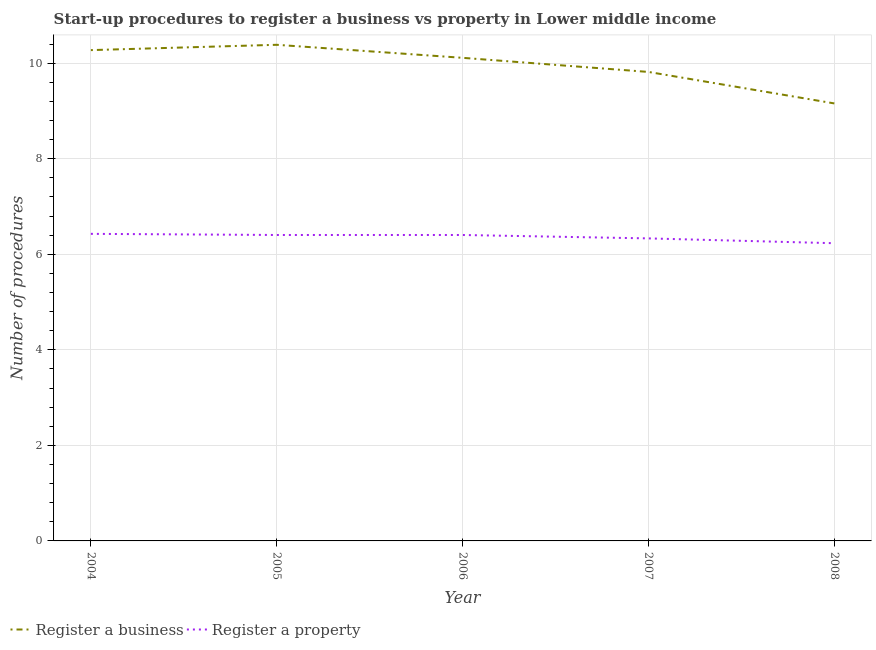How many different coloured lines are there?
Provide a succinct answer. 2. Is the number of lines equal to the number of legend labels?
Your answer should be compact. Yes. What is the number of procedures to register a business in 2006?
Provide a short and direct response. 10.11. Across all years, what is the maximum number of procedures to register a property?
Offer a very short reply. 6.43. Across all years, what is the minimum number of procedures to register a property?
Your response must be concise. 6.23. In which year was the number of procedures to register a business maximum?
Your answer should be compact. 2005. What is the total number of procedures to register a property in the graph?
Offer a very short reply. 31.8. What is the difference between the number of procedures to register a business in 2005 and that in 2007?
Your answer should be compact. 0.57. What is the difference between the number of procedures to register a business in 2005 and the number of procedures to register a property in 2006?
Keep it short and to the point. 3.98. What is the average number of procedures to register a property per year?
Make the answer very short. 6.36. In the year 2008, what is the difference between the number of procedures to register a business and number of procedures to register a property?
Ensure brevity in your answer.  2.93. What is the ratio of the number of procedures to register a business in 2004 to that in 2006?
Your answer should be very brief. 1.02. What is the difference between the highest and the second highest number of procedures to register a business?
Provide a short and direct response. 0.11. What is the difference between the highest and the lowest number of procedures to register a property?
Make the answer very short. 0.2. Is the sum of the number of procedures to register a property in 2005 and 2008 greater than the maximum number of procedures to register a business across all years?
Your response must be concise. Yes. How many years are there in the graph?
Keep it short and to the point. 5. Are the values on the major ticks of Y-axis written in scientific E-notation?
Ensure brevity in your answer.  No. Where does the legend appear in the graph?
Your response must be concise. Bottom left. How are the legend labels stacked?
Your answer should be compact. Horizontal. What is the title of the graph?
Ensure brevity in your answer.  Start-up procedures to register a business vs property in Lower middle income. Does "Excluding technical cooperation" appear as one of the legend labels in the graph?
Give a very brief answer. No. What is the label or title of the Y-axis?
Ensure brevity in your answer.  Number of procedures. What is the Number of procedures in Register a business in 2004?
Provide a short and direct response. 10.28. What is the Number of procedures in Register a property in 2004?
Offer a very short reply. 6.43. What is the Number of procedures in Register a business in 2005?
Keep it short and to the point. 10.39. What is the Number of procedures of Register a property in 2005?
Your answer should be very brief. 6.4. What is the Number of procedures of Register a business in 2006?
Provide a short and direct response. 10.11. What is the Number of procedures in Register a property in 2006?
Make the answer very short. 6.4. What is the Number of procedures of Register a business in 2007?
Keep it short and to the point. 9.82. What is the Number of procedures of Register a property in 2007?
Your answer should be compact. 6.33. What is the Number of procedures in Register a business in 2008?
Your answer should be very brief. 9.16. What is the Number of procedures in Register a property in 2008?
Your answer should be compact. 6.23. Across all years, what is the maximum Number of procedures of Register a business?
Offer a very short reply. 10.39. Across all years, what is the maximum Number of procedures in Register a property?
Your answer should be compact. 6.43. Across all years, what is the minimum Number of procedures in Register a business?
Provide a short and direct response. 9.16. Across all years, what is the minimum Number of procedures in Register a property?
Give a very brief answer. 6.23. What is the total Number of procedures of Register a business in the graph?
Provide a short and direct response. 49.75. What is the total Number of procedures of Register a property in the graph?
Offer a very short reply. 31.8. What is the difference between the Number of procedures in Register a business in 2004 and that in 2005?
Offer a very short reply. -0.11. What is the difference between the Number of procedures of Register a property in 2004 and that in 2005?
Your answer should be compact. 0.02. What is the difference between the Number of procedures of Register a business in 2004 and that in 2006?
Your response must be concise. 0.16. What is the difference between the Number of procedures in Register a property in 2004 and that in 2006?
Your answer should be very brief. 0.02. What is the difference between the Number of procedures of Register a business in 2004 and that in 2007?
Give a very brief answer. 0.46. What is the difference between the Number of procedures of Register a property in 2004 and that in 2007?
Keep it short and to the point. 0.1. What is the difference between the Number of procedures of Register a business in 2004 and that in 2008?
Ensure brevity in your answer.  1.12. What is the difference between the Number of procedures of Register a property in 2004 and that in 2008?
Provide a succinct answer. 0.2. What is the difference between the Number of procedures in Register a business in 2005 and that in 2006?
Ensure brevity in your answer.  0.27. What is the difference between the Number of procedures of Register a property in 2005 and that in 2006?
Your response must be concise. 0. What is the difference between the Number of procedures in Register a business in 2005 and that in 2007?
Offer a very short reply. 0.57. What is the difference between the Number of procedures in Register a property in 2005 and that in 2007?
Your answer should be compact. 0.07. What is the difference between the Number of procedures of Register a business in 2005 and that in 2008?
Give a very brief answer. 1.23. What is the difference between the Number of procedures in Register a property in 2005 and that in 2008?
Provide a short and direct response. 0.17. What is the difference between the Number of procedures in Register a business in 2006 and that in 2007?
Provide a short and direct response. 0.3. What is the difference between the Number of procedures of Register a property in 2006 and that in 2007?
Your response must be concise. 0.07. What is the difference between the Number of procedures of Register a business in 2006 and that in 2008?
Keep it short and to the point. 0.95. What is the difference between the Number of procedures of Register a property in 2006 and that in 2008?
Your response must be concise. 0.17. What is the difference between the Number of procedures of Register a business in 2007 and that in 2008?
Give a very brief answer. 0.66. What is the difference between the Number of procedures in Register a property in 2007 and that in 2008?
Your answer should be compact. 0.1. What is the difference between the Number of procedures in Register a business in 2004 and the Number of procedures in Register a property in 2005?
Provide a succinct answer. 3.87. What is the difference between the Number of procedures in Register a business in 2004 and the Number of procedures in Register a property in 2006?
Your answer should be very brief. 3.87. What is the difference between the Number of procedures in Register a business in 2004 and the Number of procedures in Register a property in 2007?
Offer a terse response. 3.94. What is the difference between the Number of procedures of Register a business in 2004 and the Number of procedures of Register a property in 2008?
Make the answer very short. 4.04. What is the difference between the Number of procedures in Register a business in 2005 and the Number of procedures in Register a property in 2006?
Give a very brief answer. 3.98. What is the difference between the Number of procedures of Register a business in 2005 and the Number of procedures of Register a property in 2007?
Provide a short and direct response. 4.05. What is the difference between the Number of procedures in Register a business in 2005 and the Number of procedures in Register a property in 2008?
Your answer should be very brief. 4.15. What is the difference between the Number of procedures of Register a business in 2006 and the Number of procedures of Register a property in 2007?
Ensure brevity in your answer.  3.78. What is the difference between the Number of procedures in Register a business in 2006 and the Number of procedures in Register a property in 2008?
Your response must be concise. 3.88. What is the difference between the Number of procedures in Register a business in 2007 and the Number of procedures in Register a property in 2008?
Your answer should be compact. 3.59. What is the average Number of procedures of Register a business per year?
Keep it short and to the point. 9.95. What is the average Number of procedures of Register a property per year?
Provide a short and direct response. 6.36. In the year 2004, what is the difference between the Number of procedures of Register a business and Number of procedures of Register a property?
Ensure brevity in your answer.  3.85. In the year 2005, what is the difference between the Number of procedures of Register a business and Number of procedures of Register a property?
Your response must be concise. 3.98. In the year 2006, what is the difference between the Number of procedures in Register a business and Number of procedures in Register a property?
Give a very brief answer. 3.71. In the year 2007, what is the difference between the Number of procedures of Register a business and Number of procedures of Register a property?
Make the answer very short. 3.48. In the year 2008, what is the difference between the Number of procedures of Register a business and Number of procedures of Register a property?
Offer a very short reply. 2.93. What is the ratio of the Number of procedures in Register a business in 2004 to that in 2005?
Ensure brevity in your answer.  0.99. What is the ratio of the Number of procedures of Register a business in 2004 to that in 2006?
Your response must be concise. 1.02. What is the ratio of the Number of procedures in Register a property in 2004 to that in 2006?
Offer a terse response. 1. What is the ratio of the Number of procedures of Register a business in 2004 to that in 2007?
Give a very brief answer. 1.05. What is the ratio of the Number of procedures in Register a property in 2004 to that in 2007?
Keep it short and to the point. 1.01. What is the ratio of the Number of procedures in Register a business in 2004 to that in 2008?
Offer a terse response. 1.12. What is the ratio of the Number of procedures of Register a property in 2004 to that in 2008?
Provide a short and direct response. 1.03. What is the ratio of the Number of procedures of Register a business in 2005 to that in 2007?
Your answer should be very brief. 1.06. What is the ratio of the Number of procedures of Register a property in 2005 to that in 2007?
Keep it short and to the point. 1.01. What is the ratio of the Number of procedures in Register a business in 2005 to that in 2008?
Offer a very short reply. 1.13. What is the ratio of the Number of procedures of Register a property in 2005 to that in 2008?
Offer a very short reply. 1.03. What is the ratio of the Number of procedures in Register a business in 2006 to that in 2007?
Ensure brevity in your answer.  1.03. What is the ratio of the Number of procedures in Register a property in 2006 to that in 2007?
Ensure brevity in your answer.  1.01. What is the ratio of the Number of procedures in Register a business in 2006 to that in 2008?
Provide a short and direct response. 1.1. What is the ratio of the Number of procedures in Register a property in 2006 to that in 2008?
Your answer should be compact. 1.03. What is the ratio of the Number of procedures of Register a business in 2007 to that in 2008?
Make the answer very short. 1.07. What is the ratio of the Number of procedures in Register a property in 2007 to that in 2008?
Offer a terse response. 1.02. What is the difference between the highest and the second highest Number of procedures in Register a business?
Provide a succinct answer. 0.11. What is the difference between the highest and the second highest Number of procedures of Register a property?
Ensure brevity in your answer.  0.02. What is the difference between the highest and the lowest Number of procedures in Register a business?
Provide a short and direct response. 1.23. What is the difference between the highest and the lowest Number of procedures in Register a property?
Make the answer very short. 0.2. 